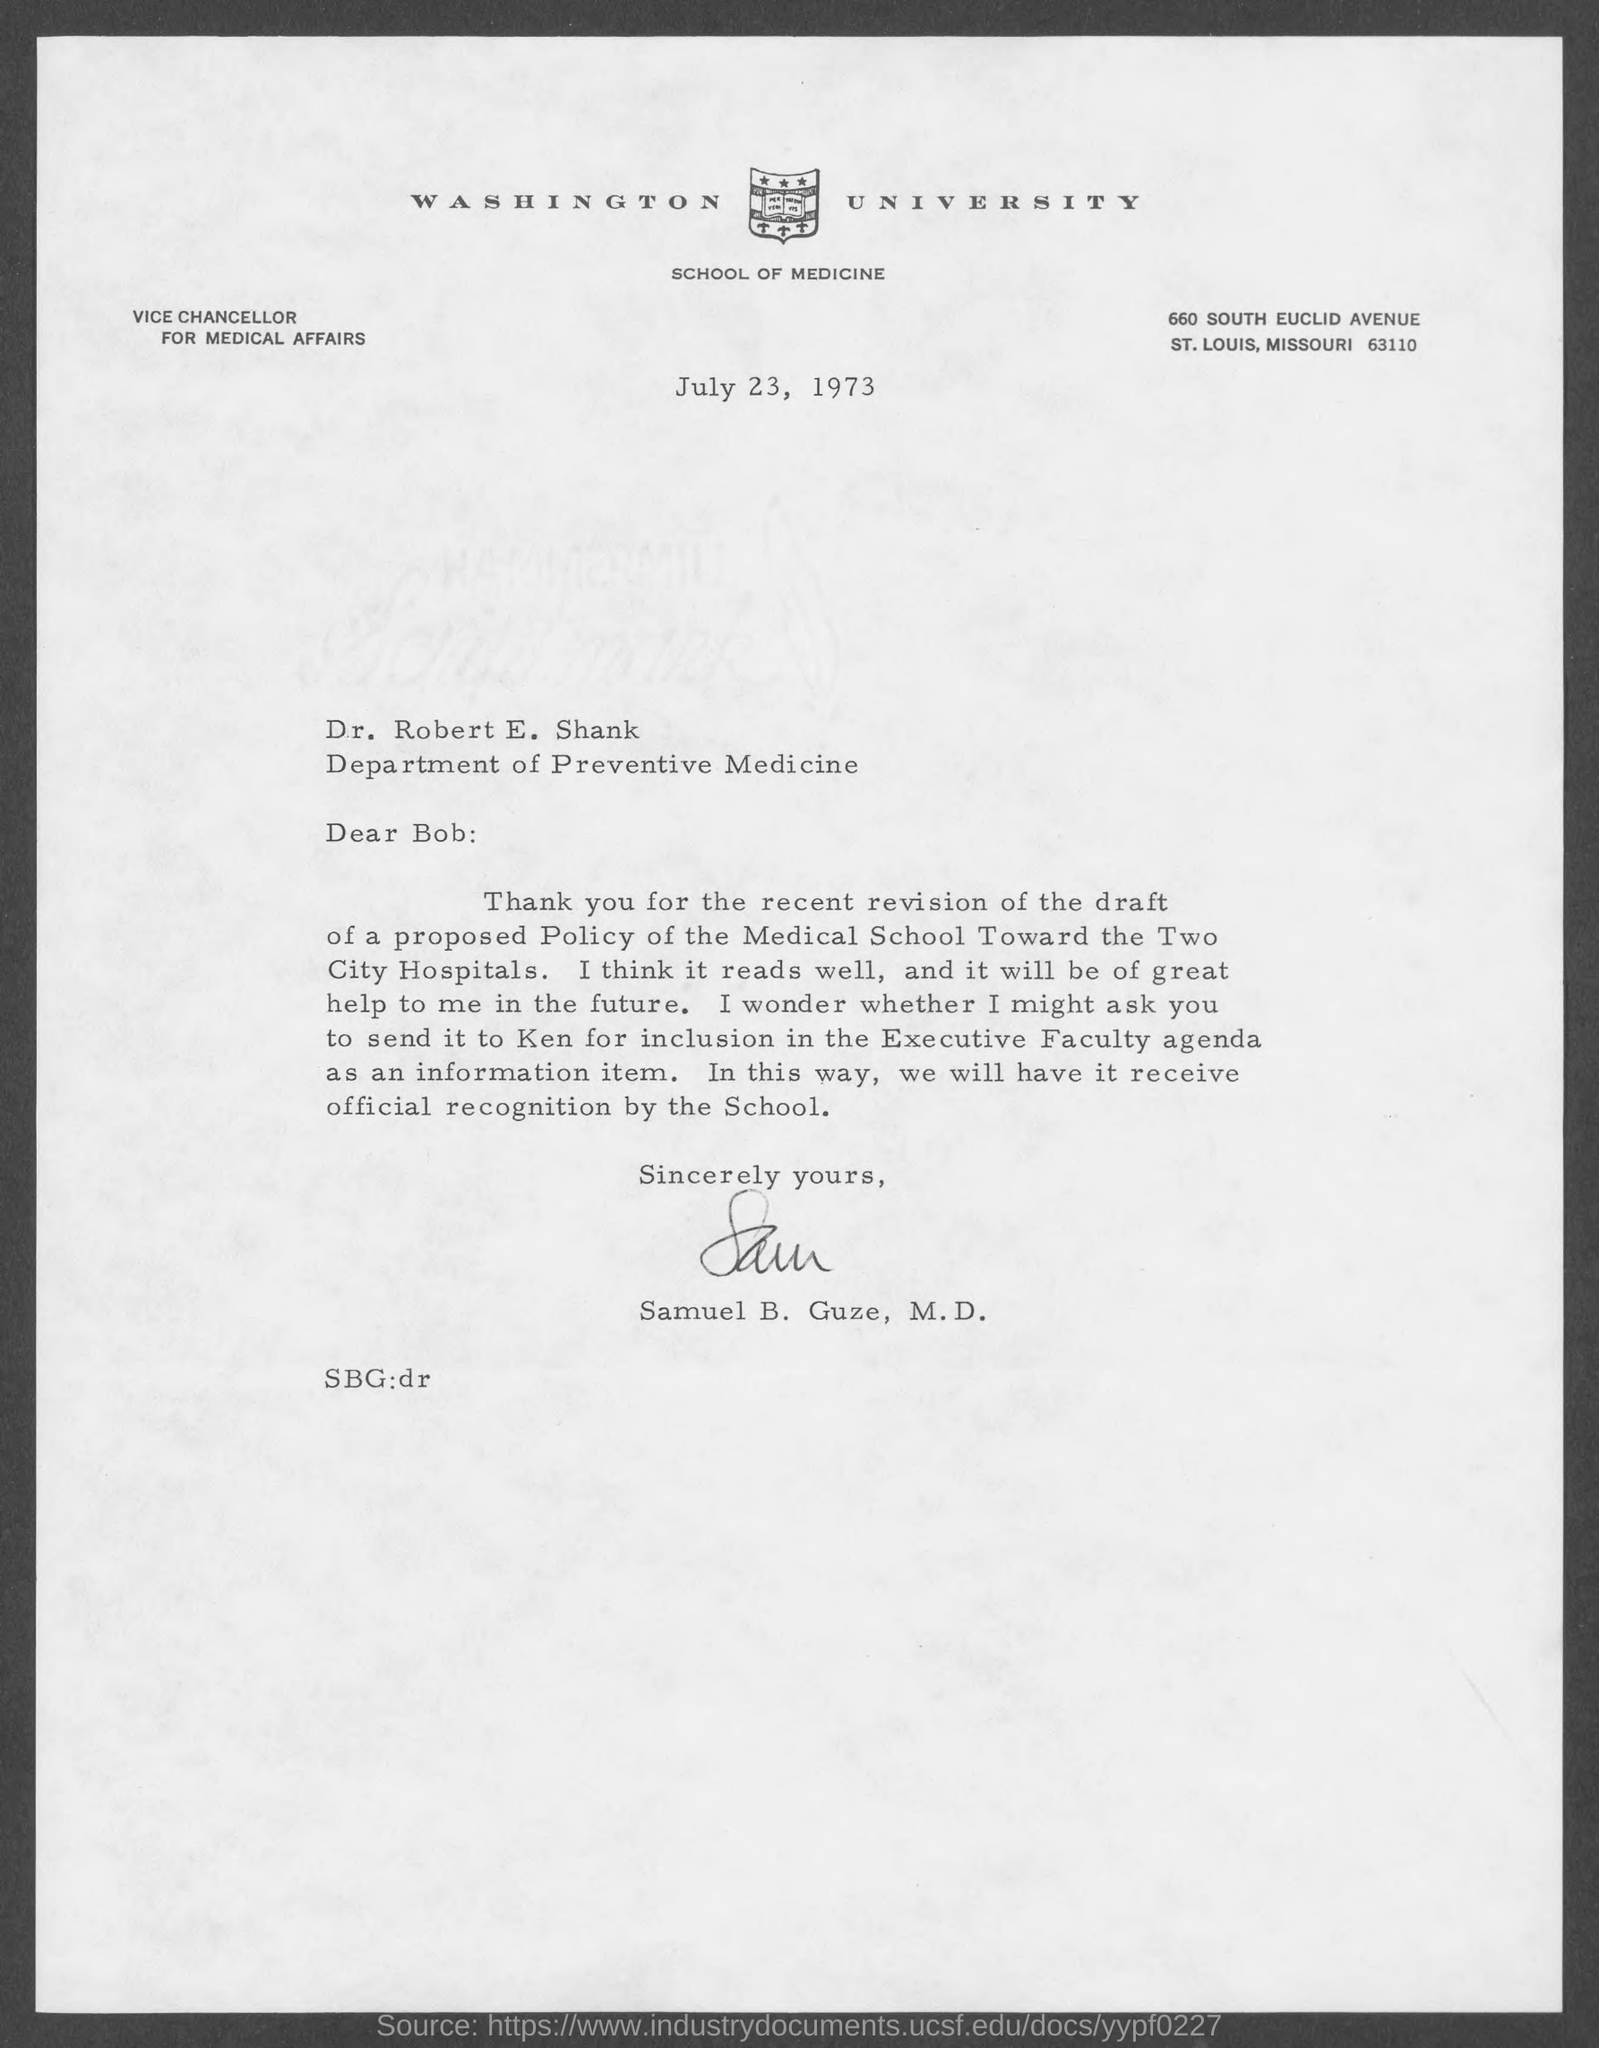What is the date on the document?
Give a very brief answer. July 23, 1973. To Whom is this letter addressed to?
Keep it short and to the point. Dr. Robert E. Shank. Who is this letter from?
Provide a succinct answer. Samuel B. Guze, M.D. Who is she asking to send it to?
Offer a very short reply. Ken. 